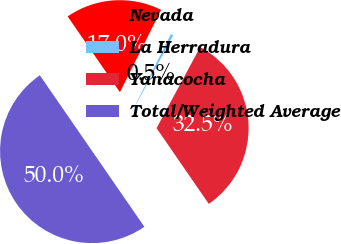<chart> <loc_0><loc_0><loc_500><loc_500><pie_chart><fcel>Nevada<fcel>La Herradura<fcel>Yanacocha<fcel>Total/Weighted Average<nl><fcel>16.99%<fcel>0.48%<fcel>32.53%<fcel>50.0%<nl></chart> 